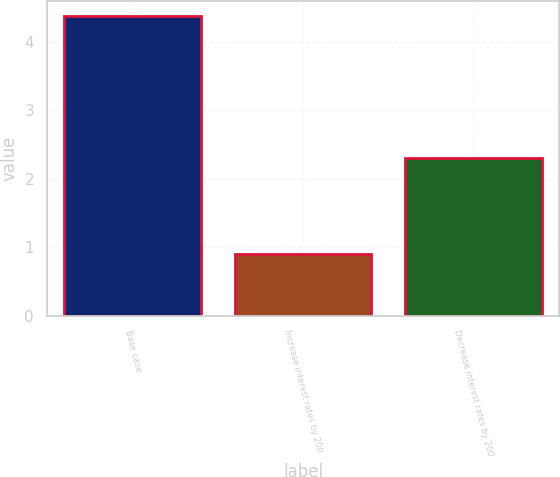<chart> <loc_0><loc_0><loc_500><loc_500><bar_chart><fcel>Base case<fcel>Increase interest rates by 200<fcel>Decrease interest rates by 200<nl><fcel>4.38<fcel>0.9<fcel>2.3<nl></chart> 